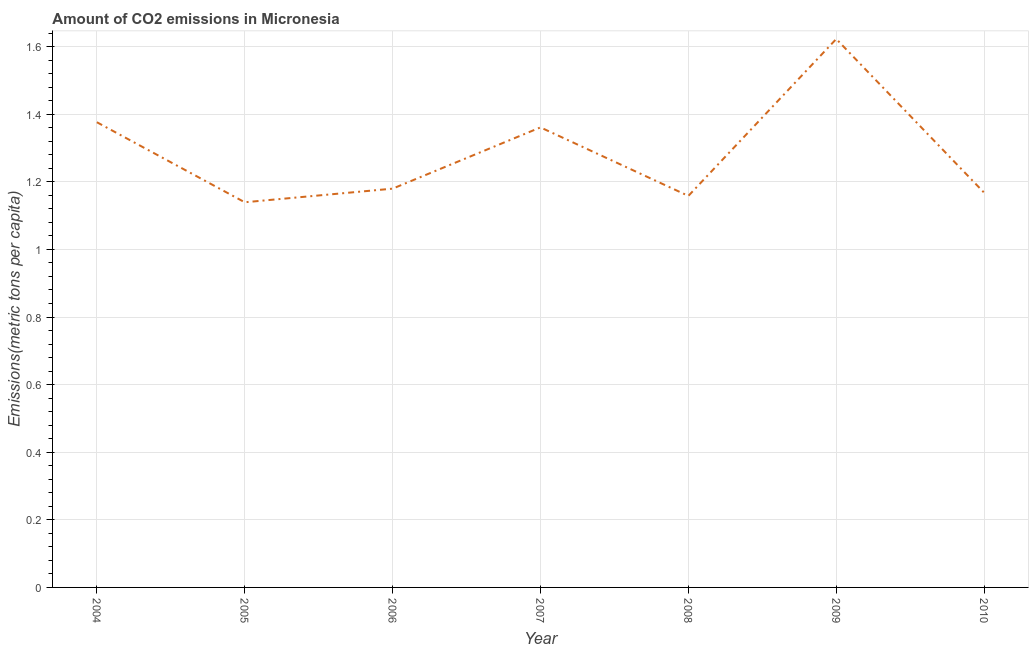What is the amount of co2 emissions in 2010?
Make the answer very short. 1.17. Across all years, what is the maximum amount of co2 emissions?
Provide a short and direct response. 1.62. Across all years, what is the minimum amount of co2 emissions?
Give a very brief answer. 1.14. In which year was the amount of co2 emissions minimum?
Provide a succinct answer. 2005. What is the sum of the amount of co2 emissions?
Your response must be concise. 9.01. What is the difference between the amount of co2 emissions in 2008 and 2010?
Provide a succinct answer. -0.01. What is the average amount of co2 emissions per year?
Give a very brief answer. 1.29. What is the median amount of co2 emissions?
Offer a very short reply. 1.18. Do a majority of the years between 2010 and 2008 (inclusive) have amount of co2 emissions greater than 0.92 metric tons per capita?
Your answer should be very brief. No. What is the ratio of the amount of co2 emissions in 2008 to that in 2009?
Offer a very short reply. 0.71. Is the amount of co2 emissions in 2004 less than that in 2010?
Provide a succinct answer. No. What is the difference between the highest and the second highest amount of co2 emissions?
Your answer should be very brief. 0.25. Is the sum of the amount of co2 emissions in 2004 and 2010 greater than the maximum amount of co2 emissions across all years?
Ensure brevity in your answer.  Yes. What is the difference between the highest and the lowest amount of co2 emissions?
Your answer should be very brief. 0.48. How many lines are there?
Offer a terse response. 1. Are the values on the major ticks of Y-axis written in scientific E-notation?
Offer a terse response. No. Does the graph contain any zero values?
Ensure brevity in your answer.  No. Does the graph contain grids?
Give a very brief answer. Yes. What is the title of the graph?
Keep it short and to the point. Amount of CO2 emissions in Micronesia. What is the label or title of the Y-axis?
Your answer should be compact. Emissions(metric tons per capita). What is the Emissions(metric tons per capita) in 2004?
Provide a short and direct response. 1.38. What is the Emissions(metric tons per capita) in 2005?
Your response must be concise. 1.14. What is the Emissions(metric tons per capita) in 2006?
Offer a very short reply. 1.18. What is the Emissions(metric tons per capita) in 2007?
Make the answer very short. 1.36. What is the Emissions(metric tons per capita) of 2008?
Offer a very short reply. 1.16. What is the Emissions(metric tons per capita) in 2009?
Keep it short and to the point. 1.62. What is the Emissions(metric tons per capita) of 2010?
Make the answer very short. 1.17. What is the difference between the Emissions(metric tons per capita) in 2004 and 2005?
Your response must be concise. 0.24. What is the difference between the Emissions(metric tons per capita) in 2004 and 2006?
Provide a succinct answer. 0.2. What is the difference between the Emissions(metric tons per capita) in 2004 and 2007?
Ensure brevity in your answer.  0.02. What is the difference between the Emissions(metric tons per capita) in 2004 and 2008?
Ensure brevity in your answer.  0.22. What is the difference between the Emissions(metric tons per capita) in 2004 and 2009?
Provide a succinct answer. -0.25. What is the difference between the Emissions(metric tons per capita) in 2004 and 2010?
Make the answer very short. 0.21. What is the difference between the Emissions(metric tons per capita) in 2005 and 2006?
Make the answer very short. -0.04. What is the difference between the Emissions(metric tons per capita) in 2005 and 2007?
Make the answer very short. -0.22. What is the difference between the Emissions(metric tons per capita) in 2005 and 2008?
Your answer should be compact. -0.02. What is the difference between the Emissions(metric tons per capita) in 2005 and 2009?
Make the answer very short. -0.48. What is the difference between the Emissions(metric tons per capita) in 2005 and 2010?
Provide a succinct answer. -0.03. What is the difference between the Emissions(metric tons per capita) in 2006 and 2007?
Provide a succinct answer. -0.18. What is the difference between the Emissions(metric tons per capita) in 2006 and 2008?
Your answer should be compact. 0.02. What is the difference between the Emissions(metric tons per capita) in 2006 and 2009?
Offer a very short reply. -0.44. What is the difference between the Emissions(metric tons per capita) in 2006 and 2010?
Your response must be concise. 0.01. What is the difference between the Emissions(metric tons per capita) in 2007 and 2008?
Ensure brevity in your answer.  0.2. What is the difference between the Emissions(metric tons per capita) in 2007 and 2009?
Offer a terse response. -0.26. What is the difference between the Emissions(metric tons per capita) in 2007 and 2010?
Offer a terse response. 0.19. What is the difference between the Emissions(metric tons per capita) in 2008 and 2009?
Provide a succinct answer. -0.46. What is the difference between the Emissions(metric tons per capita) in 2008 and 2010?
Your answer should be very brief. -0.01. What is the difference between the Emissions(metric tons per capita) in 2009 and 2010?
Offer a very short reply. 0.45. What is the ratio of the Emissions(metric tons per capita) in 2004 to that in 2005?
Give a very brief answer. 1.21. What is the ratio of the Emissions(metric tons per capita) in 2004 to that in 2006?
Provide a short and direct response. 1.17. What is the ratio of the Emissions(metric tons per capita) in 2004 to that in 2007?
Offer a very short reply. 1.01. What is the ratio of the Emissions(metric tons per capita) in 2004 to that in 2008?
Offer a very short reply. 1.19. What is the ratio of the Emissions(metric tons per capita) in 2004 to that in 2009?
Offer a terse response. 0.85. What is the ratio of the Emissions(metric tons per capita) in 2004 to that in 2010?
Give a very brief answer. 1.18. What is the ratio of the Emissions(metric tons per capita) in 2005 to that in 2006?
Provide a succinct answer. 0.97. What is the ratio of the Emissions(metric tons per capita) in 2005 to that in 2007?
Offer a very short reply. 0.84. What is the ratio of the Emissions(metric tons per capita) in 2005 to that in 2008?
Ensure brevity in your answer.  0.98. What is the ratio of the Emissions(metric tons per capita) in 2005 to that in 2009?
Offer a very short reply. 0.7. What is the ratio of the Emissions(metric tons per capita) in 2005 to that in 2010?
Keep it short and to the point. 0.98. What is the ratio of the Emissions(metric tons per capita) in 2006 to that in 2007?
Keep it short and to the point. 0.87. What is the ratio of the Emissions(metric tons per capita) in 2006 to that in 2008?
Keep it short and to the point. 1.02. What is the ratio of the Emissions(metric tons per capita) in 2006 to that in 2009?
Keep it short and to the point. 0.73. What is the ratio of the Emissions(metric tons per capita) in 2007 to that in 2008?
Ensure brevity in your answer.  1.18. What is the ratio of the Emissions(metric tons per capita) in 2007 to that in 2009?
Your answer should be compact. 0.84. What is the ratio of the Emissions(metric tons per capita) in 2007 to that in 2010?
Your answer should be compact. 1.17. What is the ratio of the Emissions(metric tons per capita) in 2008 to that in 2009?
Provide a succinct answer. 0.71. What is the ratio of the Emissions(metric tons per capita) in 2008 to that in 2010?
Your response must be concise. 0.99. What is the ratio of the Emissions(metric tons per capita) in 2009 to that in 2010?
Provide a short and direct response. 1.39. 